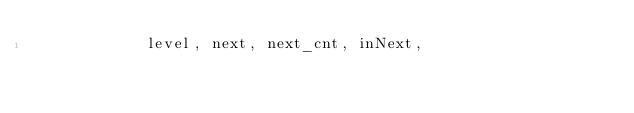<code> <loc_0><loc_0><loc_500><loc_500><_Cuda_>            level, next, next_cnt, inNext,</code> 